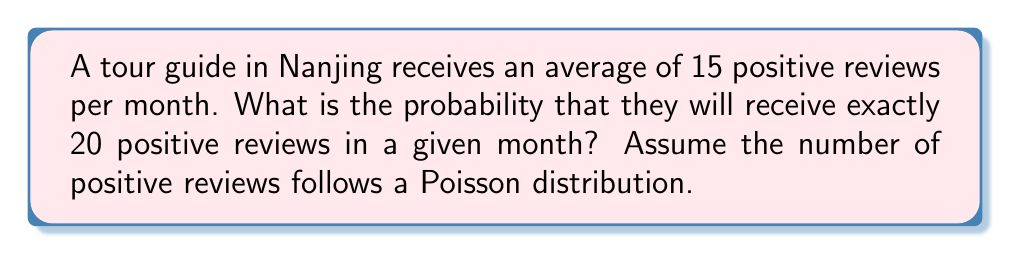Can you solve this math problem? To solve this problem, we'll use the Poisson distribution formula:

$$P(X = k) = \frac{e^{-\lambda} \lambda^k}{k!}$$

Where:
$\lambda$ = average number of events in the given time period
$k$ = number of events we're calculating the probability for
$e$ = Euler's number (approximately 2.71828)

Given:
$\lambda = 15$ (average number of positive reviews per month)
$k = 20$ (number of positive reviews we're calculating the probability for)

Step 1: Substitute the values into the Poisson distribution formula:

$$P(X = 20) = \frac{e^{-15} 15^{20}}{20!}$$

Step 2: Calculate $e^{-15}$:
$e^{-15} \approx 3.059 \times 10^{-7}$

Step 3: Calculate $15^{20}$:
$15^{20} \approx 3.269 \times 10^{23}$

Step 4: Calculate $20!$:
$20! = 2.433 \times 10^{18}$

Step 5: Substitute these values and perform the final calculation:

$$P(X = 20) = \frac{(3.059 \times 10^{-7})(3.269 \times 10^{23})}{2.433 \times 10^{18}} \approx 0.0405$$

Therefore, the probability of the tour guide receiving exactly 20 positive reviews in a given month is approximately 0.0405 or 4.05%.
Answer: $0.0405$ or $4.05\%$ 